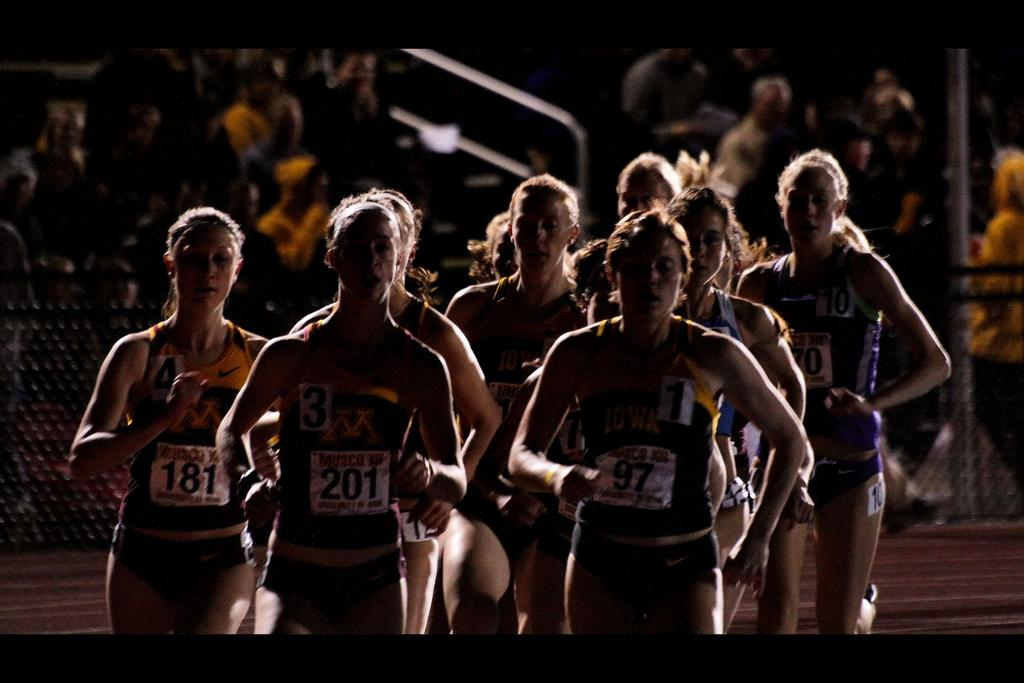What are the people in the middle of the image doing? The people in the middle of the image are running. What is located behind the people running? There is fencing behind the people running. What are the people behind the fencing doing? The people sitting behind the fencing are watching the runners. Can you describe the pole visible in the image? The pole is visible in the image, but its specific characteristics are not mentioned in the provided facts. What type of vein is visible on the runner's arm in the image? There is no visible vein on any runner's arm in the image. What color is the stranger's hat in the image? There is no stranger present in the image. 